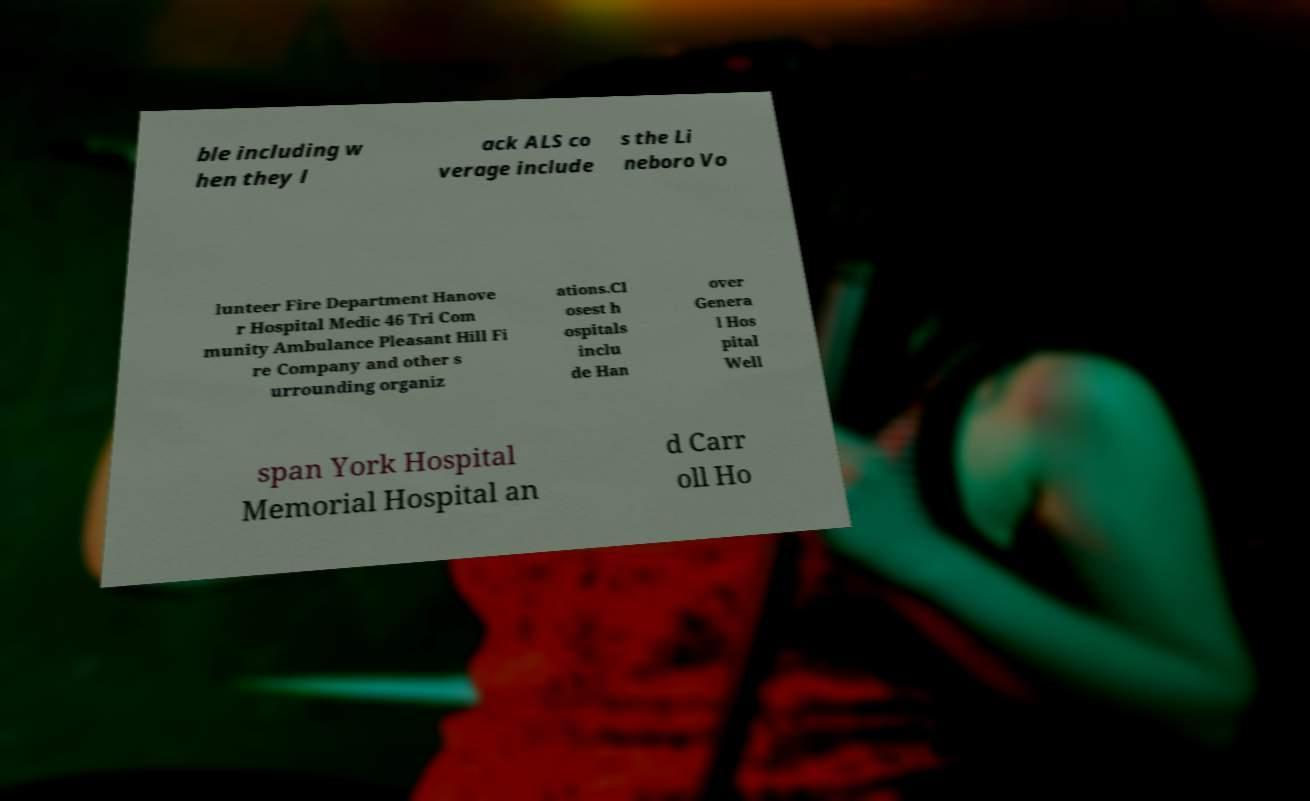Can you accurately transcribe the text from the provided image for me? ble including w hen they l ack ALS co verage include s the Li neboro Vo lunteer Fire Department Hanove r Hospital Medic 46 Tri Com munity Ambulance Pleasant Hill Fi re Company and other s urrounding organiz ations.Cl osest h ospitals inclu de Han over Genera l Hos pital Well span York Hospital Memorial Hospital an d Carr oll Ho 